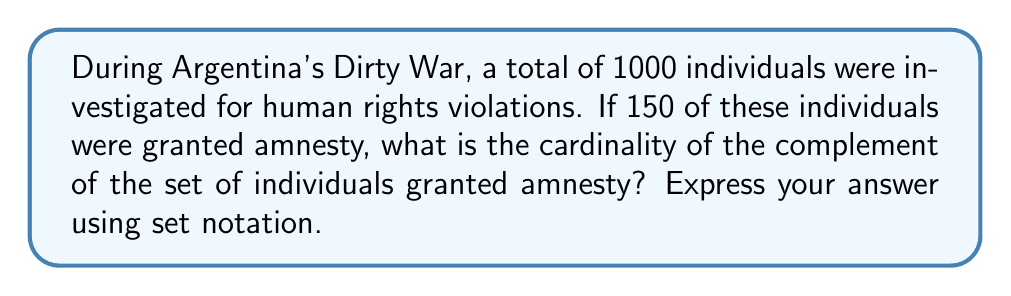What is the answer to this math problem? Let's approach this step-by-step:

1) First, let's define our universal set $U$ as all individuals investigated for human rights violations during Argentina's Dirty War. We're given that $|U| = 1000$.

2) Let $A$ be the set of individuals granted amnesty. We're told that $|A| = 150$.

3) We're asked to find the cardinality of the complement of set $A$. In set notation, the complement of $A$ is denoted as $A^c$.

4) The complement of a set contains all elements in the universal set that are not in the original set. In other words:

   $A^c = U \setminus A$

5) To find the cardinality of $A^c$, we can use the following property:

   $|A^c| = |U| - |A|$

6) Substituting the values we know:

   $|A^c| = 1000 - 150 = 850$

Therefore, the cardinality of the complement of the set of individuals granted amnesty is 850.
Answer: $|A^c| = 850$ 